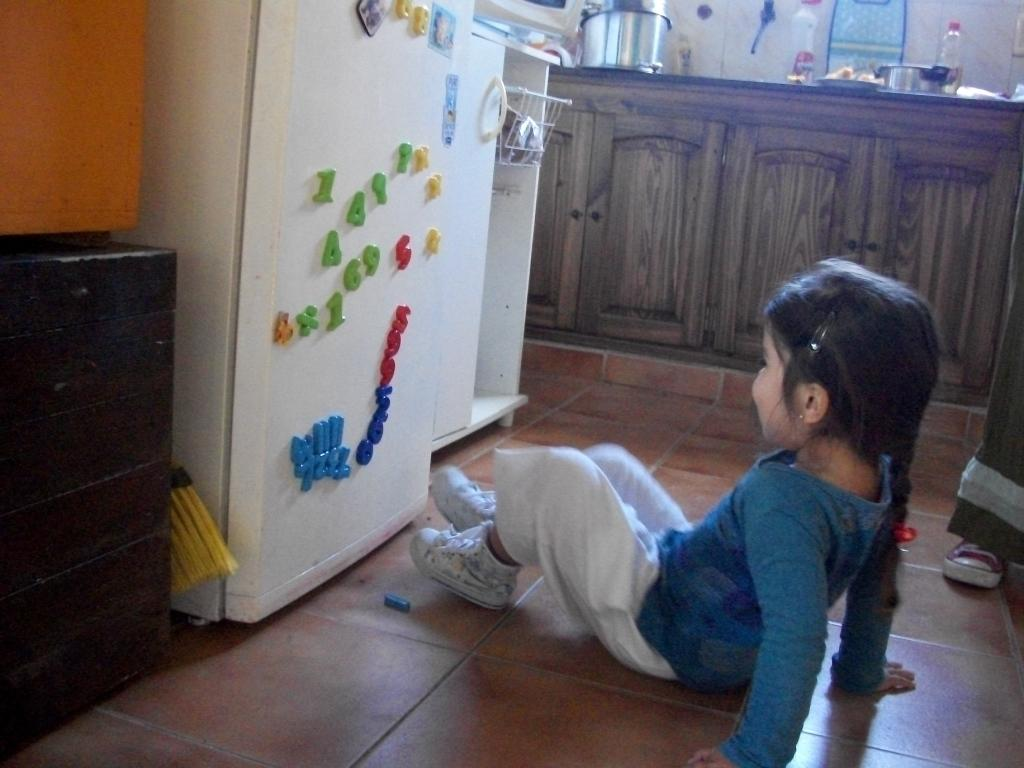<image>
Relay a brief, clear account of the picture shown. A girl sits in front of a fridge with letters including A and D on it. 